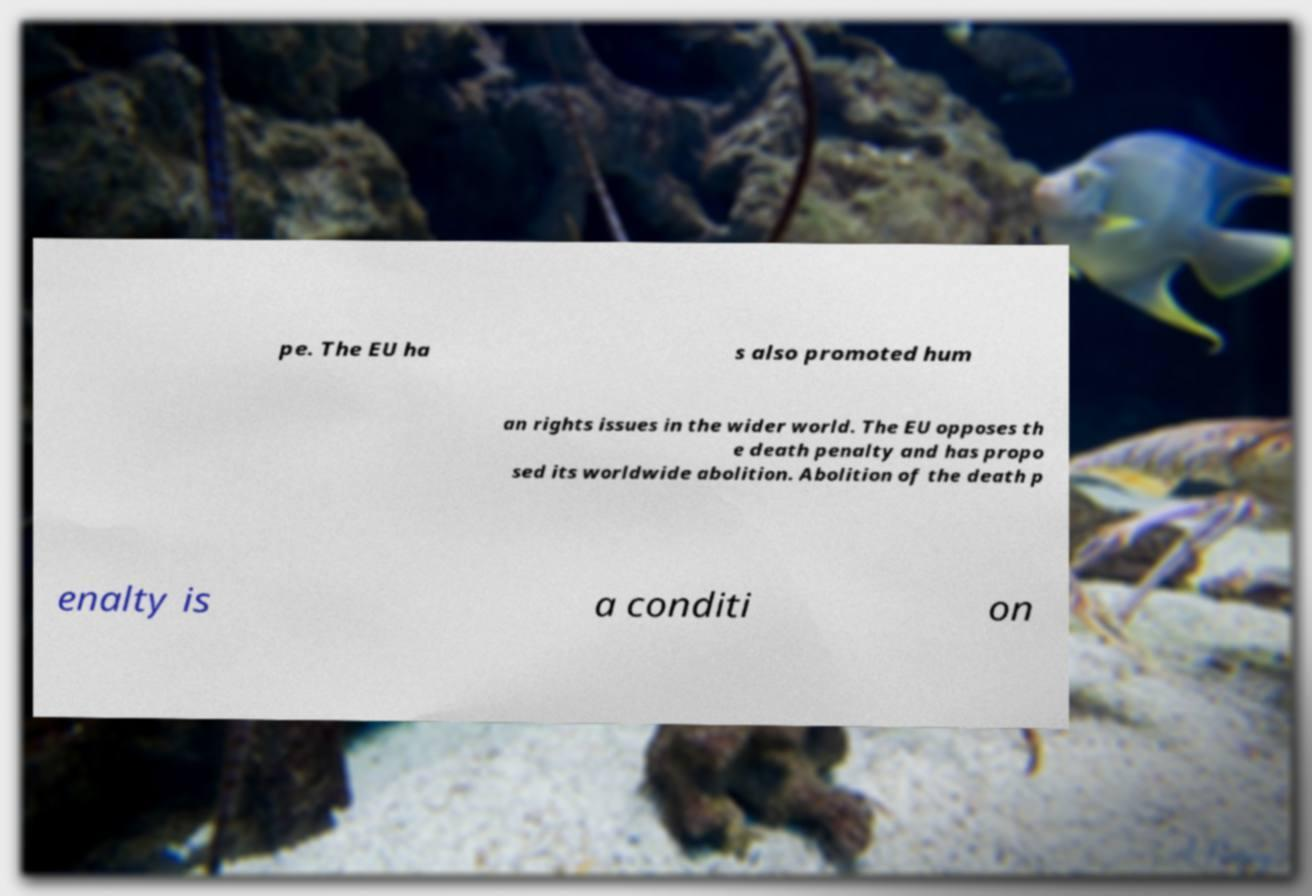There's text embedded in this image that I need extracted. Can you transcribe it verbatim? pe. The EU ha s also promoted hum an rights issues in the wider world. The EU opposes th e death penalty and has propo sed its worldwide abolition. Abolition of the death p enalty is a conditi on 